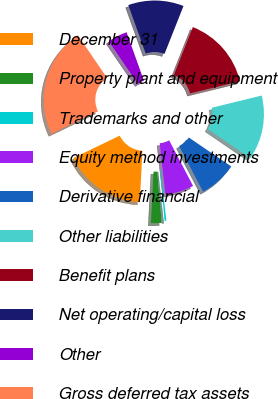Convert chart to OTSL. <chart><loc_0><loc_0><loc_500><loc_500><pie_chart><fcel>December 31<fcel>Property plant and equipment<fcel>Trademarks and other<fcel>Equity method investments<fcel>Derivative financial<fcel>Other liabilities<fcel>Benefit plans<fcel>Net operating/capital loss<fcel>Other<fcel>Gross deferred tax assets<nl><fcel>17.04%<fcel>2.22%<fcel>0.36%<fcel>5.92%<fcel>7.78%<fcel>13.34%<fcel>15.19%<fcel>11.48%<fcel>4.07%<fcel>22.6%<nl></chart> 